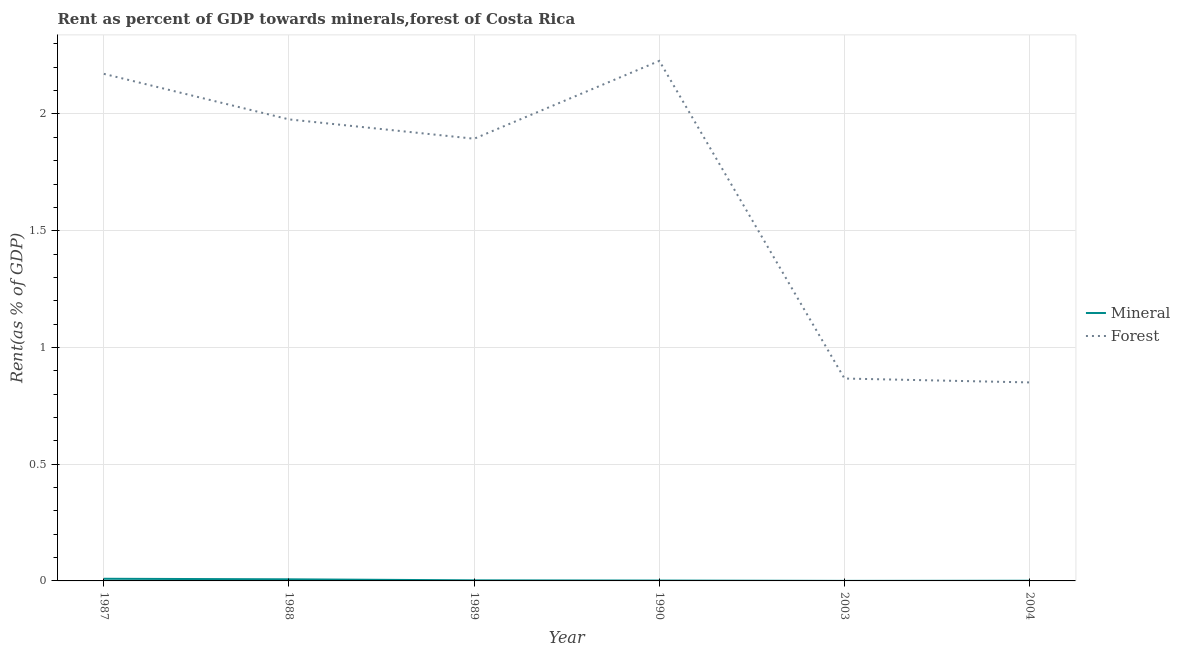What is the mineral rent in 1988?
Make the answer very short. 0.01. Across all years, what is the maximum mineral rent?
Offer a terse response. 0.01. Across all years, what is the minimum mineral rent?
Offer a very short reply. 0. What is the total forest rent in the graph?
Your answer should be very brief. 9.99. What is the difference between the mineral rent in 1988 and that in 1989?
Provide a short and direct response. 0. What is the difference between the forest rent in 1990 and the mineral rent in 1988?
Offer a terse response. 2.22. What is the average mineral rent per year?
Your answer should be very brief. 0. In the year 2003, what is the difference between the mineral rent and forest rent?
Give a very brief answer. -0.87. What is the ratio of the mineral rent in 1988 to that in 1990?
Keep it short and to the point. 4.32. Is the forest rent in 1987 less than that in 1990?
Provide a succinct answer. Yes. What is the difference between the highest and the second highest forest rent?
Provide a succinct answer. 0.06. What is the difference between the highest and the lowest mineral rent?
Provide a short and direct response. 0.01. Does the forest rent monotonically increase over the years?
Give a very brief answer. No. Is the forest rent strictly greater than the mineral rent over the years?
Your answer should be very brief. Yes. Is the mineral rent strictly less than the forest rent over the years?
Provide a short and direct response. Yes. How many lines are there?
Give a very brief answer. 2. Are the values on the major ticks of Y-axis written in scientific E-notation?
Offer a very short reply. No. Does the graph contain any zero values?
Provide a succinct answer. No. Does the graph contain grids?
Ensure brevity in your answer.  Yes. Where does the legend appear in the graph?
Your answer should be compact. Center right. How many legend labels are there?
Offer a very short reply. 2. How are the legend labels stacked?
Offer a terse response. Vertical. What is the title of the graph?
Keep it short and to the point. Rent as percent of GDP towards minerals,forest of Costa Rica. What is the label or title of the Y-axis?
Offer a terse response. Rent(as % of GDP). What is the Rent(as % of GDP) in Mineral in 1987?
Provide a short and direct response. 0.01. What is the Rent(as % of GDP) in Forest in 1987?
Your answer should be very brief. 2.17. What is the Rent(as % of GDP) of Mineral in 1988?
Your answer should be compact. 0.01. What is the Rent(as % of GDP) in Forest in 1988?
Ensure brevity in your answer.  1.98. What is the Rent(as % of GDP) in Mineral in 1989?
Ensure brevity in your answer.  0. What is the Rent(as % of GDP) of Forest in 1989?
Offer a very short reply. 1.89. What is the Rent(as % of GDP) in Mineral in 1990?
Offer a very short reply. 0. What is the Rent(as % of GDP) of Forest in 1990?
Provide a succinct answer. 2.23. What is the Rent(as % of GDP) in Mineral in 2003?
Keep it short and to the point. 0. What is the Rent(as % of GDP) of Forest in 2003?
Keep it short and to the point. 0.87. What is the Rent(as % of GDP) of Mineral in 2004?
Provide a short and direct response. 0. What is the Rent(as % of GDP) of Forest in 2004?
Your answer should be compact. 0.85. Across all years, what is the maximum Rent(as % of GDP) of Mineral?
Your answer should be very brief. 0.01. Across all years, what is the maximum Rent(as % of GDP) of Forest?
Your answer should be very brief. 2.23. Across all years, what is the minimum Rent(as % of GDP) in Mineral?
Offer a terse response. 0. Across all years, what is the minimum Rent(as % of GDP) of Forest?
Your answer should be compact. 0.85. What is the total Rent(as % of GDP) in Mineral in the graph?
Ensure brevity in your answer.  0.02. What is the total Rent(as % of GDP) of Forest in the graph?
Offer a very short reply. 9.99. What is the difference between the Rent(as % of GDP) in Mineral in 1987 and that in 1988?
Keep it short and to the point. 0. What is the difference between the Rent(as % of GDP) in Forest in 1987 and that in 1988?
Provide a succinct answer. 0.2. What is the difference between the Rent(as % of GDP) in Mineral in 1987 and that in 1989?
Ensure brevity in your answer.  0.01. What is the difference between the Rent(as % of GDP) in Forest in 1987 and that in 1989?
Provide a short and direct response. 0.28. What is the difference between the Rent(as % of GDP) in Mineral in 1987 and that in 1990?
Make the answer very short. 0.01. What is the difference between the Rent(as % of GDP) in Forest in 1987 and that in 1990?
Your answer should be very brief. -0.06. What is the difference between the Rent(as % of GDP) in Mineral in 1987 and that in 2003?
Provide a short and direct response. 0.01. What is the difference between the Rent(as % of GDP) of Forest in 1987 and that in 2003?
Keep it short and to the point. 1.3. What is the difference between the Rent(as % of GDP) in Mineral in 1987 and that in 2004?
Provide a short and direct response. 0.01. What is the difference between the Rent(as % of GDP) in Forest in 1987 and that in 2004?
Provide a succinct answer. 1.32. What is the difference between the Rent(as % of GDP) of Mineral in 1988 and that in 1989?
Your answer should be compact. 0. What is the difference between the Rent(as % of GDP) of Forest in 1988 and that in 1989?
Make the answer very short. 0.08. What is the difference between the Rent(as % of GDP) of Mineral in 1988 and that in 1990?
Keep it short and to the point. 0.01. What is the difference between the Rent(as % of GDP) of Forest in 1988 and that in 1990?
Your answer should be very brief. -0.25. What is the difference between the Rent(as % of GDP) in Mineral in 1988 and that in 2003?
Keep it short and to the point. 0.01. What is the difference between the Rent(as % of GDP) in Forest in 1988 and that in 2003?
Ensure brevity in your answer.  1.11. What is the difference between the Rent(as % of GDP) in Mineral in 1988 and that in 2004?
Ensure brevity in your answer.  0.01. What is the difference between the Rent(as % of GDP) in Forest in 1988 and that in 2004?
Give a very brief answer. 1.13. What is the difference between the Rent(as % of GDP) of Mineral in 1989 and that in 1990?
Ensure brevity in your answer.  0. What is the difference between the Rent(as % of GDP) in Forest in 1989 and that in 1990?
Your answer should be compact. -0.33. What is the difference between the Rent(as % of GDP) of Mineral in 1989 and that in 2003?
Give a very brief answer. 0. What is the difference between the Rent(as % of GDP) of Forest in 1989 and that in 2003?
Your answer should be compact. 1.03. What is the difference between the Rent(as % of GDP) of Mineral in 1989 and that in 2004?
Ensure brevity in your answer.  0. What is the difference between the Rent(as % of GDP) of Forest in 1989 and that in 2004?
Provide a short and direct response. 1.04. What is the difference between the Rent(as % of GDP) in Mineral in 1990 and that in 2003?
Your response must be concise. 0. What is the difference between the Rent(as % of GDP) of Forest in 1990 and that in 2003?
Your answer should be compact. 1.36. What is the difference between the Rent(as % of GDP) of Mineral in 1990 and that in 2004?
Provide a short and direct response. 0. What is the difference between the Rent(as % of GDP) of Forest in 1990 and that in 2004?
Offer a terse response. 1.38. What is the difference between the Rent(as % of GDP) in Mineral in 2003 and that in 2004?
Make the answer very short. -0. What is the difference between the Rent(as % of GDP) in Forest in 2003 and that in 2004?
Offer a very short reply. 0.02. What is the difference between the Rent(as % of GDP) in Mineral in 1987 and the Rent(as % of GDP) in Forest in 1988?
Your answer should be compact. -1.97. What is the difference between the Rent(as % of GDP) in Mineral in 1987 and the Rent(as % of GDP) in Forest in 1989?
Provide a succinct answer. -1.88. What is the difference between the Rent(as % of GDP) in Mineral in 1987 and the Rent(as % of GDP) in Forest in 1990?
Offer a very short reply. -2.22. What is the difference between the Rent(as % of GDP) of Mineral in 1987 and the Rent(as % of GDP) of Forest in 2003?
Make the answer very short. -0.86. What is the difference between the Rent(as % of GDP) of Mineral in 1987 and the Rent(as % of GDP) of Forest in 2004?
Ensure brevity in your answer.  -0.84. What is the difference between the Rent(as % of GDP) of Mineral in 1988 and the Rent(as % of GDP) of Forest in 1989?
Keep it short and to the point. -1.89. What is the difference between the Rent(as % of GDP) in Mineral in 1988 and the Rent(as % of GDP) in Forest in 1990?
Keep it short and to the point. -2.22. What is the difference between the Rent(as % of GDP) of Mineral in 1988 and the Rent(as % of GDP) of Forest in 2003?
Make the answer very short. -0.86. What is the difference between the Rent(as % of GDP) in Mineral in 1988 and the Rent(as % of GDP) in Forest in 2004?
Provide a short and direct response. -0.84. What is the difference between the Rent(as % of GDP) of Mineral in 1989 and the Rent(as % of GDP) of Forest in 1990?
Provide a succinct answer. -2.22. What is the difference between the Rent(as % of GDP) of Mineral in 1989 and the Rent(as % of GDP) of Forest in 2003?
Offer a terse response. -0.86. What is the difference between the Rent(as % of GDP) of Mineral in 1989 and the Rent(as % of GDP) of Forest in 2004?
Your answer should be very brief. -0.85. What is the difference between the Rent(as % of GDP) of Mineral in 1990 and the Rent(as % of GDP) of Forest in 2003?
Provide a short and direct response. -0.87. What is the difference between the Rent(as % of GDP) in Mineral in 1990 and the Rent(as % of GDP) in Forest in 2004?
Keep it short and to the point. -0.85. What is the difference between the Rent(as % of GDP) of Mineral in 2003 and the Rent(as % of GDP) of Forest in 2004?
Keep it short and to the point. -0.85. What is the average Rent(as % of GDP) in Mineral per year?
Your response must be concise. 0. What is the average Rent(as % of GDP) of Forest per year?
Offer a very short reply. 1.66. In the year 1987, what is the difference between the Rent(as % of GDP) of Mineral and Rent(as % of GDP) of Forest?
Provide a succinct answer. -2.16. In the year 1988, what is the difference between the Rent(as % of GDP) in Mineral and Rent(as % of GDP) in Forest?
Offer a terse response. -1.97. In the year 1989, what is the difference between the Rent(as % of GDP) in Mineral and Rent(as % of GDP) in Forest?
Offer a very short reply. -1.89. In the year 1990, what is the difference between the Rent(as % of GDP) of Mineral and Rent(as % of GDP) of Forest?
Make the answer very short. -2.23. In the year 2003, what is the difference between the Rent(as % of GDP) in Mineral and Rent(as % of GDP) in Forest?
Ensure brevity in your answer.  -0.87. In the year 2004, what is the difference between the Rent(as % of GDP) of Mineral and Rent(as % of GDP) of Forest?
Give a very brief answer. -0.85. What is the ratio of the Rent(as % of GDP) of Mineral in 1987 to that in 1988?
Give a very brief answer. 1.35. What is the ratio of the Rent(as % of GDP) of Forest in 1987 to that in 1988?
Provide a succinct answer. 1.1. What is the ratio of the Rent(as % of GDP) of Mineral in 1987 to that in 1989?
Give a very brief answer. 3.72. What is the ratio of the Rent(as % of GDP) of Forest in 1987 to that in 1989?
Offer a very short reply. 1.15. What is the ratio of the Rent(as % of GDP) in Mineral in 1987 to that in 1990?
Keep it short and to the point. 5.82. What is the ratio of the Rent(as % of GDP) in Mineral in 1987 to that in 2003?
Your answer should be compact. 48.13. What is the ratio of the Rent(as % of GDP) in Forest in 1987 to that in 2003?
Offer a very short reply. 2.51. What is the ratio of the Rent(as % of GDP) of Mineral in 1987 to that in 2004?
Your answer should be very brief. 11.44. What is the ratio of the Rent(as % of GDP) in Forest in 1987 to that in 2004?
Your answer should be compact. 2.55. What is the ratio of the Rent(as % of GDP) in Mineral in 1988 to that in 1989?
Offer a terse response. 2.76. What is the ratio of the Rent(as % of GDP) in Forest in 1988 to that in 1989?
Ensure brevity in your answer.  1.04. What is the ratio of the Rent(as % of GDP) of Mineral in 1988 to that in 1990?
Your response must be concise. 4.32. What is the ratio of the Rent(as % of GDP) of Forest in 1988 to that in 1990?
Your answer should be compact. 0.89. What is the ratio of the Rent(as % of GDP) in Mineral in 1988 to that in 2003?
Keep it short and to the point. 35.7. What is the ratio of the Rent(as % of GDP) in Forest in 1988 to that in 2003?
Keep it short and to the point. 2.28. What is the ratio of the Rent(as % of GDP) of Mineral in 1988 to that in 2004?
Give a very brief answer. 8.48. What is the ratio of the Rent(as % of GDP) in Forest in 1988 to that in 2004?
Provide a succinct answer. 2.33. What is the ratio of the Rent(as % of GDP) of Mineral in 1989 to that in 1990?
Give a very brief answer. 1.57. What is the ratio of the Rent(as % of GDP) in Forest in 1989 to that in 1990?
Make the answer very short. 0.85. What is the ratio of the Rent(as % of GDP) of Mineral in 1989 to that in 2003?
Provide a short and direct response. 12.94. What is the ratio of the Rent(as % of GDP) in Forest in 1989 to that in 2003?
Provide a succinct answer. 2.18. What is the ratio of the Rent(as % of GDP) of Mineral in 1989 to that in 2004?
Your answer should be very brief. 3.08. What is the ratio of the Rent(as % of GDP) of Forest in 1989 to that in 2004?
Your answer should be very brief. 2.23. What is the ratio of the Rent(as % of GDP) of Mineral in 1990 to that in 2003?
Give a very brief answer. 8.26. What is the ratio of the Rent(as % of GDP) of Forest in 1990 to that in 2003?
Provide a succinct answer. 2.57. What is the ratio of the Rent(as % of GDP) of Mineral in 1990 to that in 2004?
Provide a succinct answer. 1.96. What is the ratio of the Rent(as % of GDP) of Forest in 1990 to that in 2004?
Ensure brevity in your answer.  2.62. What is the ratio of the Rent(as % of GDP) in Mineral in 2003 to that in 2004?
Offer a very short reply. 0.24. What is the ratio of the Rent(as % of GDP) of Forest in 2003 to that in 2004?
Keep it short and to the point. 1.02. What is the difference between the highest and the second highest Rent(as % of GDP) in Mineral?
Make the answer very short. 0. What is the difference between the highest and the second highest Rent(as % of GDP) of Forest?
Your answer should be very brief. 0.06. What is the difference between the highest and the lowest Rent(as % of GDP) in Mineral?
Keep it short and to the point. 0.01. What is the difference between the highest and the lowest Rent(as % of GDP) in Forest?
Offer a very short reply. 1.38. 